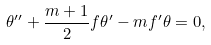<formula> <loc_0><loc_0><loc_500><loc_500>\theta ^ { \prime \prime } + \frac { m + 1 } { 2 } f \theta ^ { \prime } - m f ^ { \prime } \theta = 0 ,</formula> 